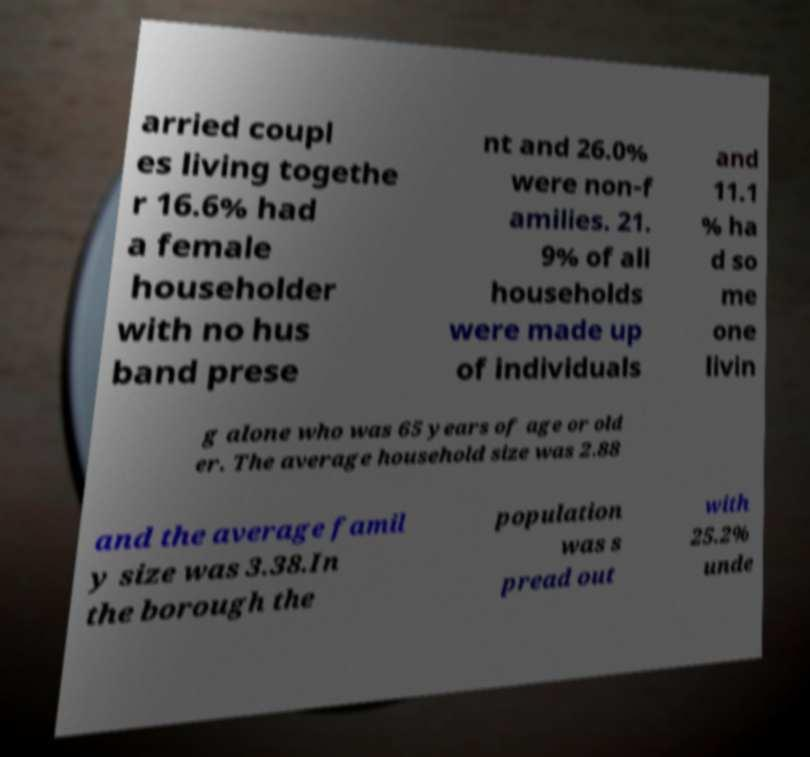I need the written content from this picture converted into text. Can you do that? arried coupl es living togethe r 16.6% had a female householder with no hus band prese nt and 26.0% were non-f amilies. 21. 9% of all households were made up of individuals and 11.1 % ha d so me one livin g alone who was 65 years of age or old er. The average household size was 2.88 and the average famil y size was 3.38.In the borough the population was s pread out with 25.2% unde 